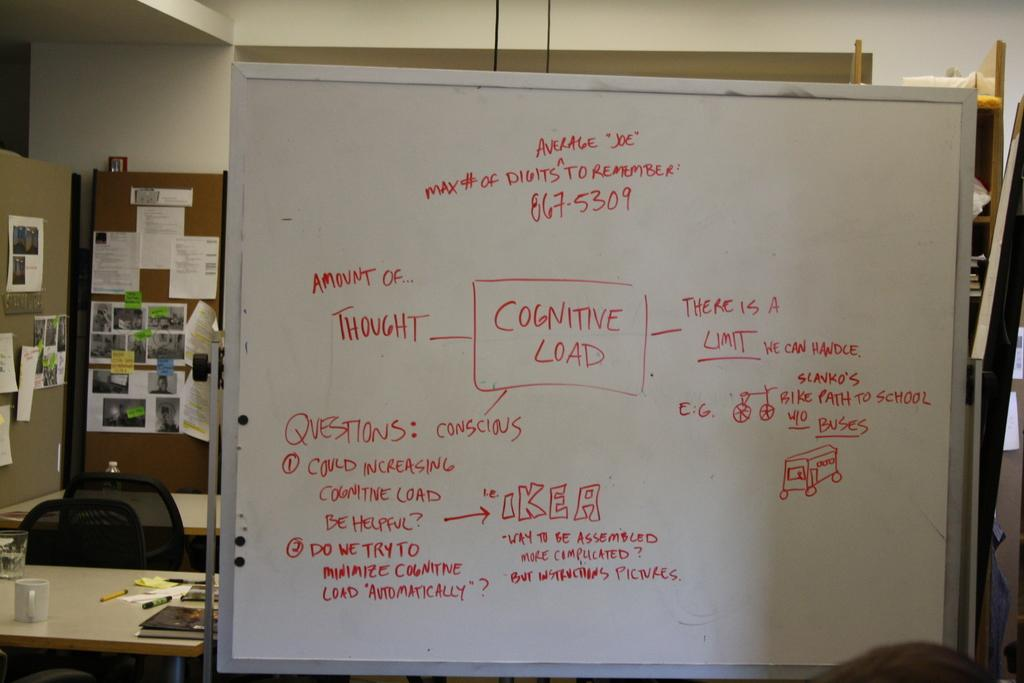<image>
Present a compact description of the photo's key features. A white board full of red writing with the word cognitive load in a square 